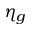Convert formula to latex. <formula><loc_0><loc_0><loc_500><loc_500>\eta _ { g }</formula> 